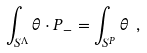<formula> <loc_0><loc_0><loc_500><loc_500>\int _ { S ^ { \Lambda } } \theta \cdot P _ { - } = \int _ { S ^ { P } } \theta \ ,</formula> 